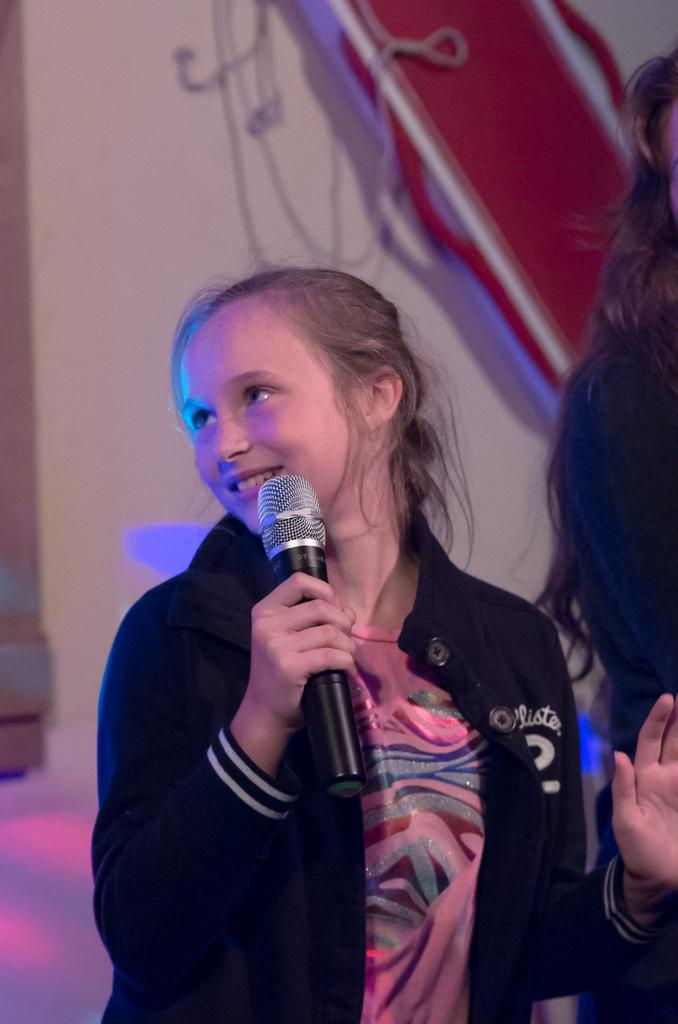Who is the main subject in the image? There is a girl in the image. What is the girl holding in the image? The girl is holding a microphone. What is the girl's facial expression in the image? The girl is smiling. What can be seen in the background of the image? There is a white wall in the background of the image. Can you describe the design on the white wall? The white wall has a red design. What type of bun is the girl holding in the image? There is no bun present in the image; the girl is holding a microphone. How many knees are visible in the image? There is no mention of knees in the image; it features a girl holding a microphone in front of a white wall with a red design. 